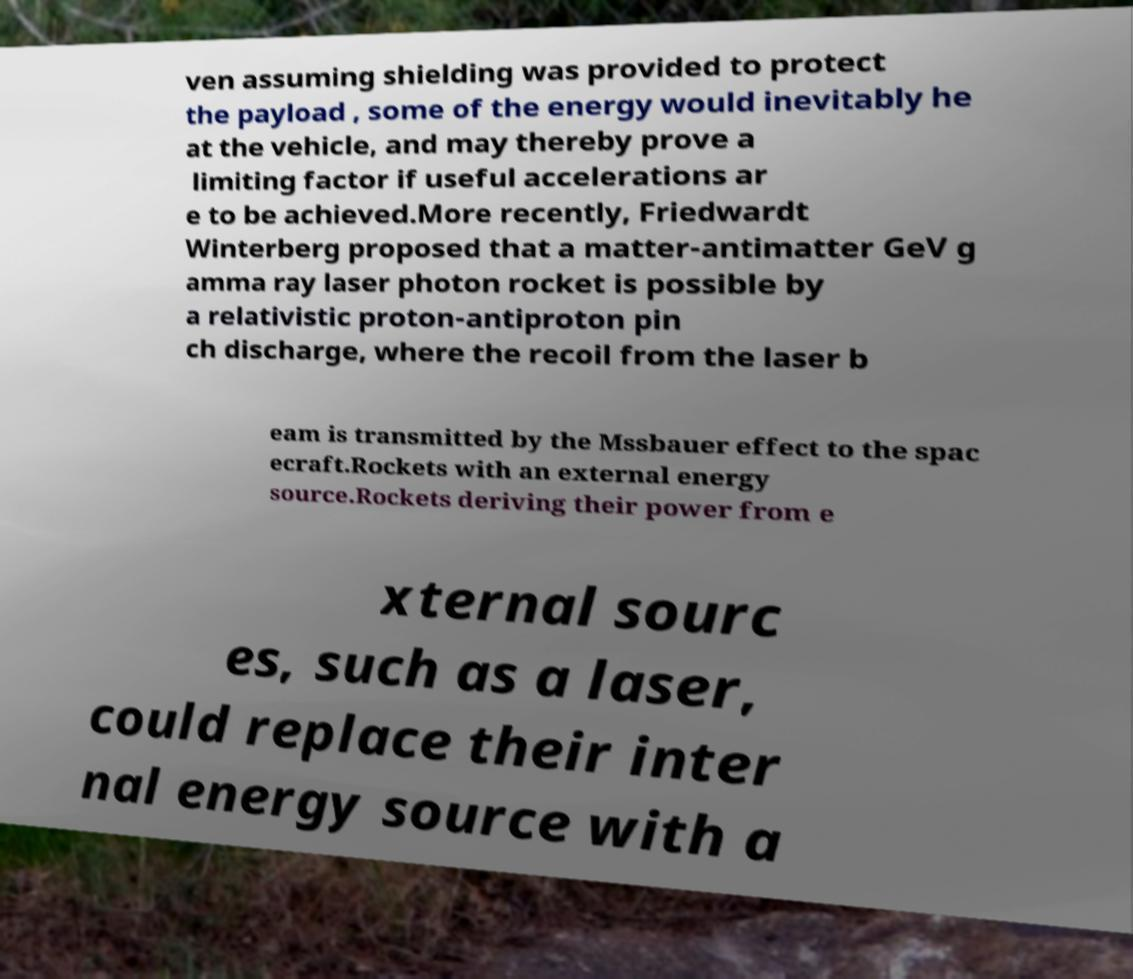Please identify and transcribe the text found in this image. ven assuming shielding was provided to protect the payload , some of the energy would inevitably he at the vehicle, and may thereby prove a limiting factor if useful accelerations ar e to be achieved.More recently, Friedwardt Winterberg proposed that a matter-antimatter GeV g amma ray laser photon rocket is possible by a relativistic proton-antiproton pin ch discharge, where the recoil from the laser b eam is transmitted by the Mssbauer effect to the spac ecraft.Rockets with an external energy source.Rockets deriving their power from e xternal sourc es, such as a laser, could replace their inter nal energy source with a 